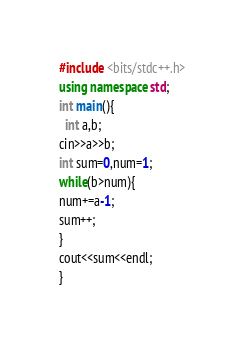Convert code to text. <code><loc_0><loc_0><loc_500><loc_500><_C++_>#include <bits/stdc++.h>
using namespace std;
int main(){
  int a,b;
cin>>a>>b;
int sum=0,num=1;
while(b>num){
num+=a-1;
sum++;
}
cout<<sum<<endl;
}  </code> 